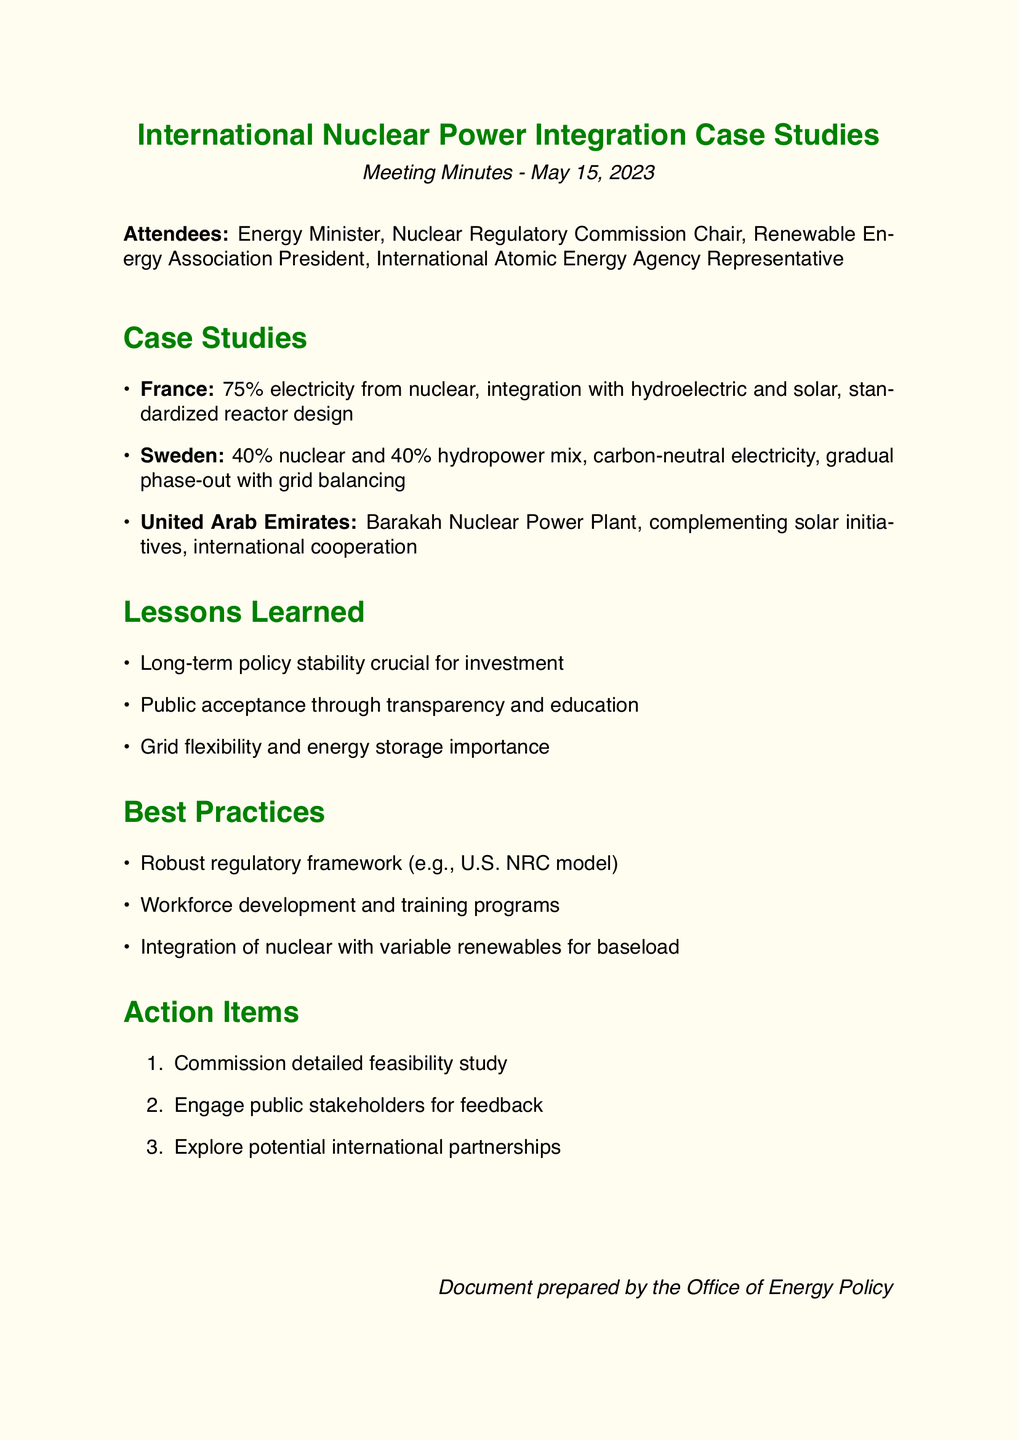What percentage of electricity in France comes from nuclear power? The document states that 75% of electricity in France comes from nuclear power.
Answer: 75% What is the nuclear power percentage combined with hydropower in Sweden? The document specifies that Sweden has a nuclear percentage of 40% combined with 40% hydropower.
Answer: 40% What was a crucial factor for investment highlighted in the lessons learned? The lessons learned section identifies long-term policy stability as crucial for investment.
Answer: Long-term policy stability What is one of the best practices mentioned regarding regulatory frameworks? The document mentions a robust regulatory framework, specifically citing the U.S. NRC model.
Answer: U.S. NRC model How many action items were listed in the document? The document contains three action items listed under the Action Items section.
Answer: Three What key aspect contributed to public acceptance in nuclear power integration? The document notes that public acceptance can be achieved through transparency and education.
Answer: Transparency and education Which case study focuses on international cooperation in nuclear power integration? The United Arab Emirates case study emphasizes international cooperation and knowledge transfer.
Answer: United Arab Emirates What type of member is the Renewable Energy Association President classified as? The document lists the Renewable Energy Association President as one of the attendees.
Answer: Attendee 